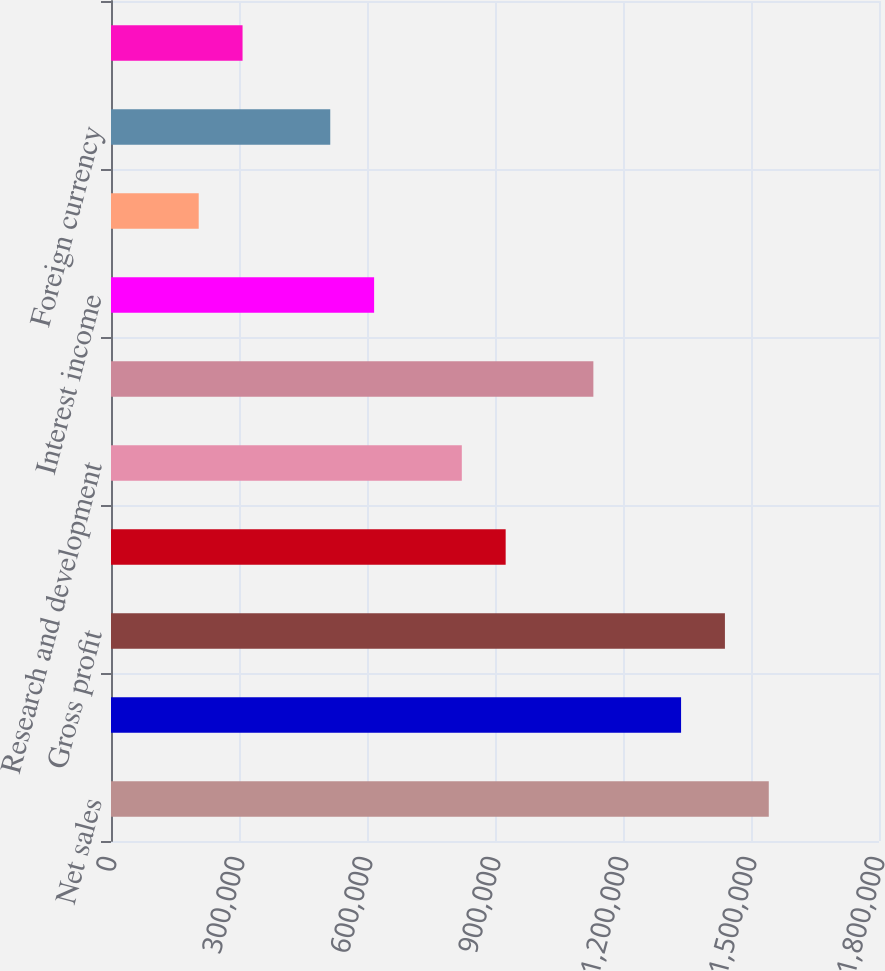<chart> <loc_0><loc_0><loc_500><loc_500><bar_chart><fcel>Net sales<fcel>Cost of goods sold<fcel>Gross profit<fcel>Selling general and<fcel>Research and development<fcel>Operating income<fcel>Interest income<fcel>Interest expense<fcel>Foreign currency<fcel>Other<nl><fcel>1.54166e+06<fcel>1.3361e+06<fcel>1.43888e+06<fcel>924996<fcel>822219<fcel>1.13055e+06<fcel>616664<fcel>205556<fcel>513887<fcel>308333<nl></chart> 